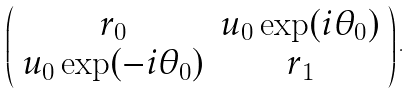<formula> <loc_0><loc_0><loc_500><loc_500>\left ( \begin{array} { c c } r _ { 0 } & u _ { 0 } \exp ( i \theta _ { 0 } ) \\ u _ { 0 } \exp ( - i \theta _ { 0 } ) & r _ { 1 } \end{array} \right ) .</formula> 